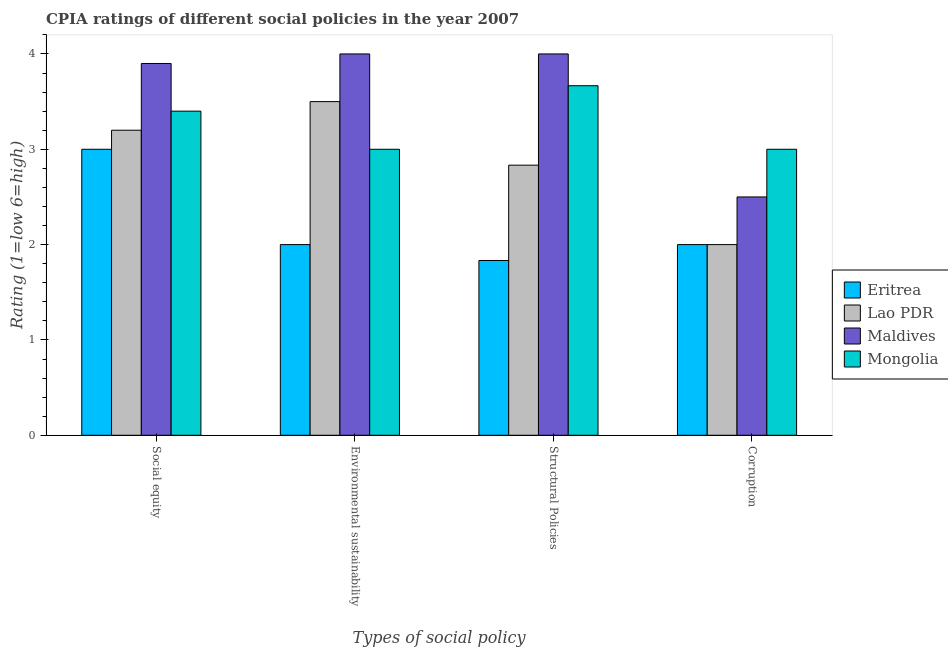How many different coloured bars are there?
Give a very brief answer. 4. How many groups of bars are there?
Give a very brief answer. 4. Are the number of bars per tick equal to the number of legend labels?
Keep it short and to the point. Yes. Are the number of bars on each tick of the X-axis equal?
Keep it short and to the point. Yes. What is the label of the 3rd group of bars from the left?
Provide a succinct answer. Structural Policies. In which country was the cpia rating of environmental sustainability maximum?
Ensure brevity in your answer.  Maldives. In which country was the cpia rating of structural policies minimum?
Your answer should be compact. Eritrea. What is the total cpia rating of corruption in the graph?
Offer a terse response. 9.5. What is the difference between the cpia rating of environmental sustainability in Maldives and that in Lao PDR?
Make the answer very short. 0.5. What is the difference between the cpia rating of social equity in Lao PDR and the cpia rating of structural policies in Eritrea?
Your response must be concise. 1.37. What is the average cpia rating of environmental sustainability per country?
Your response must be concise. 3.12. What is the difference between the cpia rating of social equity and cpia rating of environmental sustainability in Eritrea?
Give a very brief answer. 1. What is the ratio of the cpia rating of corruption in Maldives to that in Mongolia?
Ensure brevity in your answer.  0.83. Is the cpia rating of structural policies in Eritrea less than that in Lao PDR?
Offer a very short reply. Yes. What is the difference between the highest and the lowest cpia rating of corruption?
Your answer should be very brief. 1. In how many countries, is the cpia rating of social equity greater than the average cpia rating of social equity taken over all countries?
Provide a short and direct response. 2. Is it the case that in every country, the sum of the cpia rating of corruption and cpia rating of structural policies is greater than the sum of cpia rating of environmental sustainability and cpia rating of social equity?
Give a very brief answer. No. What does the 3rd bar from the left in Environmental sustainability represents?
Your answer should be very brief. Maldives. What does the 4th bar from the right in Environmental sustainability represents?
Your answer should be very brief. Eritrea. Is it the case that in every country, the sum of the cpia rating of social equity and cpia rating of environmental sustainability is greater than the cpia rating of structural policies?
Ensure brevity in your answer.  Yes. How many bars are there?
Your response must be concise. 16. Are all the bars in the graph horizontal?
Give a very brief answer. No. How many countries are there in the graph?
Provide a succinct answer. 4. Are the values on the major ticks of Y-axis written in scientific E-notation?
Make the answer very short. No. How are the legend labels stacked?
Provide a succinct answer. Vertical. What is the title of the graph?
Offer a very short reply. CPIA ratings of different social policies in the year 2007. Does "Belarus" appear as one of the legend labels in the graph?
Provide a succinct answer. No. What is the label or title of the X-axis?
Ensure brevity in your answer.  Types of social policy. What is the Rating (1=low 6=high) in Lao PDR in Social equity?
Ensure brevity in your answer.  3.2. What is the Rating (1=low 6=high) in Maldives in Social equity?
Provide a succinct answer. 3.9. What is the Rating (1=low 6=high) in Mongolia in Social equity?
Keep it short and to the point. 3.4. What is the Rating (1=low 6=high) of Lao PDR in Environmental sustainability?
Provide a succinct answer. 3.5. What is the Rating (1=low 6=high) of Maldives in Environmental sustainability?
Your answer should be compact. 4. What is the Rating (1=low 6=high) of Eritrea in Structural Policies?
Keep it short and to the point. 1.83. What is the Rating (1=low 6=high) of Lao PDR in Structural Policies?
Your answer should be very brief. 2.83. What is the Rating (1=low 6=high) in Maldives in Structural Policies?
Offer a very short reply. 4. What is the Rating (1=low 6=high) in Mongolia in Structural Policies?
Provide a succinct answer. 3.67. What is the Rating (1=low 6=high) of Mongolia in Corruption?
Provide a succinct answer. 3. Across all Types of social policy, what is the maximum Rating (1=low 6=high) of Mongolia?
Your answer should be compact. 3.67. Across all Types of social policy, what is the minimum Rating (1=low 6=high) in Eritrea?
Offer a very short reply. 1.83. Across all Types of social policy, what is the minimum Rating (1=low 6=high) of Lao PDR?
Provide a succinct answer. 2. Across all Types of social policy, what is the minimum Rating (1=low 6=high) of Mongolia?
Your response must be concise. 3. What is the total Rating (1=low 6=high) in Eritrea in the graph?
Your response must be concise. 8.83. What is the total Rating (1=low 6=high) in Lao PDR in the graph?
Make the answer very short. 11.53. What is the total Rating (1=low 6=high) in Mongolia in the graph?
Keep it short and to the point. 13.07. What is the difference between the Rating (1=low 6=high) of Maldives in Social equity and that in Environmental sustainability?
Keep it short and to the point. -0.1. What is the difference between the Rating (1=low 6=high) in Mongolia in Social equity and that in Environmental sustainability?
Provide a succinct answer. 0.4. What is the difference between the Rating (1=low 6=high) of Lao PDR in Social equity and that in Structural Policies?
Provide a short and direct response. 0.37. What is the difference between the Rating (1=low 6=high) in Mongolia in Social equity and that in Structural Policies?
Keep it short and to the point. -0.27. What is the difference between the Rating (1=low 6=high) of Lao PDR in Social equity and that in Corruption?
Make the answer very short. 1.2. What is the difference between the Rating (1=low 6=high) in Maldives in Social equity and that in Corruption?
Your answer should be very brief. 1.4. What is the difference between the Rating (1=low 6=high) of Eritrea in Environmental sustainability and that in Structural Policies?
Provide a succinct answer. 0.17. What is the difference between the Rating (1=low 6=high) of Lao PDR in Environmental sustainability and that in Structural Policies?
Ensure brevity in your answer.  0.67. What is the difference between the Rating (1=low 6=high) in Maldives in Environmental sustainability and that in Structural Policies?
Your answer should be compact. 0. What is the difference between the Rating (1=low 6=high) of Mongolia in Environmental sustainability and that in Structural Policies?
Keep it short and to the point. -0.67. What is the difference between the Rating (1=low 6=high) of Mongolia in Environmental sustainability and that in Corruption?
Give a very brief answer. 0. What is the difference between the Rating (1=low 6=high) in Eritrea in Social equity and the Rating (1=low 6=high) in Maldives in Environmental sustainability?
Give a very brief answer. -1. What is the difference between the Rating (1=low 6=high) of Eritrea in Social equity and the Rating (1=low 6=high) of Mongolia in Environmental sustainability?
Your answer should be compact. 0. What is the difference between the Rating (1=low 6=high) in Maldives in Social equity and the Rating (1=low 6=high) in Mongolia in Environmental sustainability?
Your answer should be very brief. 0.9. What is the difference between the Rating (1=low 6=high) of Eritrea in Social equity and the Rating (1=low 6=high) of Maldives in Structural Policies?
Give a very brief answer. -1. What is the difference between the Rating (1=low 6=high) in Eritrea in Social equity and the Rating (1=low 6=high) in Mongolia in Structural Policies?
Offer a very short reply. -0.67. What is the difference between the Rating (1=low 6=high) in Lao PDR in Social equity and the Rating (1=low 6=high) in Maldives in Structural Policies?
Keep it short and to the point. -0.8. What is the difference between the Rating (1=low 6=high) in Lao PDR in Social equity and the Rating (1=low 6=high) in Mongolia in Structural Policies?
Offer a terse response. -0.47. What is the difference between the Rating (1=low 6=high) in Maldives in Social equity and the Rating (1=low 6=high) in Mongolia in Structural Policies?
Your answer should be very brief. 0.23. What is the difference between the Rating (1=low 6=high) of Eritrea in Social equity and the Rating (1=low 6=high) of Lao PDR in Corruption?
Give a very brief answer. 1. What is the difference between the Rating (1=low 6=high) of Eritrea in Social equity and the Rating (1=low 6=high) of Maldives in Corruption?
Provide a short and direct response. 0.5. What is the difference between the Rating (1=low 6=high) in Lao PDR in Social equity and the Rating (1=low 6=high) in Mongolia in Corruption?
Provide a short and direct response. 0.2. What is the difference between the Rating (1=low 6=high) of Maldives in Social equity and the Rating (1=low 6=high) of Mongolia in Corruption?
Your response must be concise. 0.9. What is the difference between the Rating (1=low 6=high) in Eritrea in Environmental sustainability and the Rating (1=low 6=high) in Lao PDR in Structural Policies?
Offer a very short reply. -0.83. What is the difference between the Rating (1=low 6=high) of Eritrea in Environmental sustainability and the Rating (1=low 6=high) of Mongolia in Structural Policies?
Provide a short and direct response. -1.67. What is the difference between the Rating (1=low 6=high) in Lao PDR in Environmental sustainability and the Rating (1=low 6=high) in Maldives in Structural Policies?
Provide a short and direct response. -0.5. What is the difference between the Rating (1=low 6=high) in Lao PDR in Environmental sustainability and the Rating (1=low 6=high) in Mongolia in Structural Policies?
Make the answer very short. -0.17. What is the difference between the Rating (1=low 6=high) of Eritrea in Environmental sustainability and the Rating (1=low 6=high) of Lao PDR in Corruption?
Offer a very short reply. 0. What is the difference between the Rating (1=low 6=high) of Lao PDR in Environmental sustainability and the Rating (1=low 6=high) of Maldives in Corruption?
Offer a very short reply. 1. What is the difference between the Rating (1=low 6=high) in Eritrea in Structural Policies and the Rating (1=low 6=high) in Lao PDR in Corruption?
Your answer should be compact. -0.17. What is the difference between the Rating (1=low 6=high) in Eritrea in Structural Policies and the Rating (1=low 6=high) in Maldives in Corruption?
Provide a succinct answer. -0.67. What is the difference between the Rating (1=low 6=high) of Eritrea in Structural Policies and the Rating (1=low 6=high) of Mongolia in Corruption?
Provide a succinct answer. -1.17. What is the difference between the Rating (1=low 6=high) of Lao PDR in Structural Policies and the Rating (1=low 6=high) of Maldives in Corruption?
Your answer should be very brief. 0.33. What is the difference between the Rating (1=low 6=high) of Maldives in Structural Policies and the Rating (1=low 6=high) of Mongolia in Corruption?
Your response must be concise. 1. What is the average Rating (1=low 6=high) of Eritrea per Types of social policy?
Give a very brief answer. 2.21. What is the average Rating (1=low 6=high) of Lao PDR per Types of social policy?
Provide a short and direct response. 2.88. What is the average Rating (1=low 6=high) of Maldives per Types of social policy?
Provide a succinct answer. 3.6. What is the average Rating (1=low 6=high) in Mongolia per Types of social policy?
Give a very brief answer. 3.27. What is the difference between the Rating (1=low 6=high) in Eritrea and Rating (1=low 6=high) in Maldives in Social equity?
Give a very brief answer. -0.9. What is the difference between the Rating (1=low 6=high) in Lao PDR and Rating (1=low 6=high) in Maldives in Social equity?
Offer a terse response. -0.7. What is the difference between the Rating (1=low 6=high) in Lao PDR and Rating (1=low 6=high) in Mongolia in Social equity?
Ensure brevity in your answer.  -0.2. What is the difference between the Rating (1=low 6=high) in Eritrea and Rating (1=low 6=high) in Lao PDR in Environmental sustainability?
Offer a very short reply. -1.5. What is the difference between the Rating (1=low 6=high) of Eritrea and Rating (1=low 6=high) of Mongolia in Environmental sustainability?
Make the answer very short. -1. What is the difference between the Rating (1=low 6=high) in Lao PDR and Rating (1=low 6=high) in Mongolia in Environmental sustainability?
Your answer should be compact. 0.5. What is the difference between the Rating (1=low 6=high) in Eritrea and Rating (1=low 6=high) in Lao PDR in Structural Policies?
Your answer should be very brief. -1. What is the difference between the Rating (1=low 6=high) of Eritrea and Rating (1=low 6=high) of Maldives in Structural Policies?
Your answer should be compact. -2.17. What is the difference between the Rating (1=low 6=high) in Eritrea and Rating (1=low 6=high) in Mongolia in Structural Policies?
Give a very brief answer. -1.83. What is the difference between the Rating (1=low 6=high) of Lao PDR and Rating (1=low 6=high) of Maldives in Structural Policies?
Provide a short and direct response. -1.17. What is the difference between the Rating (1=low 6=high) of Eritrea and Rating (1=low 6=high) of Lao PDR in Corruption?
Provide a short and direct response. 0. What is the difference between the Rating (1=low 6=high) of Eritrea and Rating (1=low 6=high) of Maldives in Corruption?
Offer a very short reply. -0.5. What is the difference between the Rating (1=low 6=high) in Eritrea and Rating (1=low 6=high) in Mongolia in Corruption?
Keep it short and to the point. -1. What is the difference between the Rating (1=low 6=high) of Maldives and Rating (1=low 6=high) of Mongolia in Corruption?
Make the answer very short. -0.5. What is the ratio of the Rating (1=low 6=high) in Lao PDR in Social equity to that in Environmental sustainability?
Keep it short and to the point. 0.91. What is the ratio of the Rating (1=low 6=high) of Mongolia in Social equity to that in Environmental sustainability?
Provide a short and direct response. 1.13. What is the ratio of the Rating (1=low 6=high) in Eritrea in Social equity to that in Structural Policies?
Your answer should be very brief. 1.64. What is the ratio of the Rating (1=low 6=high) of Lao PDR in Social equity to that in Structural Policies?
Your answer should be very brief. 1.13. What is the ratio of the Rating (1=low 6=high) of Mongolia in Social equity to that in Structural Policies?
Keep it short and to the point. 0.93. What is the ratio of the Rating (1=low 6=high) of Eritrea in Social equity to that in Corruption?
Give a very brief answer. 1.5. What is the ratio of the Rating (1=low 6=high) of Lao PDR in Social equity to that in Corruption?
Make the answer very short. 1.6. What is the ratio of the Rating (1=low 6=high) in Maldives in Social equity to that in Corruption?
Make the answer very short. 1.56. What is the ratio of the Rating (1=low 6=high) in Mongolia in Social equity to that in Corruption?
Your answer should be compact. 1.13. What is the ratio of the Rating (1=low 6=high) of Lao PDR in Environmental sustainability to that in Structural Policies?
Your response must be concise. 1.24. What is the ratio of the Rating (1=low 6=high) of Mongolia in Environmental sustainability to that in Structural Policies?
Offer a very short reply. 0.82. What is the ratio of the Rating (1=low 6=high) of Maldives in Environmental sustainability to that in Corruption?
Keep it short and to the point. 1.6. What is the ratio of the Rating (1=low 6=high) of Eritrea in Structural Policies to that in Corruption?
Offer a terse response. 0.92. What is the ratio of the Rating (1=low 6=high) in Lao PDR in Structural Policies to that in Corruption?
Offer a terse response. 1.42. What is the ratio of the Rating (1=low 6=high) of Mongolia in Structural Policies to that in Corruption?
Your response must be concise. 1.22. What is the difference between the highest and the second highest Rating (1=low 6=high) in Eritrea?
Give a very brief answer. 1. What is the difference between the highest and the second highest Rating (1=low 6=high) in Lao PDR?
Offer a very short reply. 0.3. What is the difference between the highest and the second highest Rating (1=low 6=high) in Maldives?
Keep it short and to the point. 0. What is the difference between the highest and the second highest Rating (1=low 6=high) in Mongolia?
Provide a short and direct response. 0.27. What is the difference between the highest and the lowest Rating (1=low 6=high) of Eritrea?
Offer a very short reply. 1.17. What is the difference between the highest and the lowest Rating (1=low 6=high) of Maldives?
Provide a succinct answer. 1.5. 